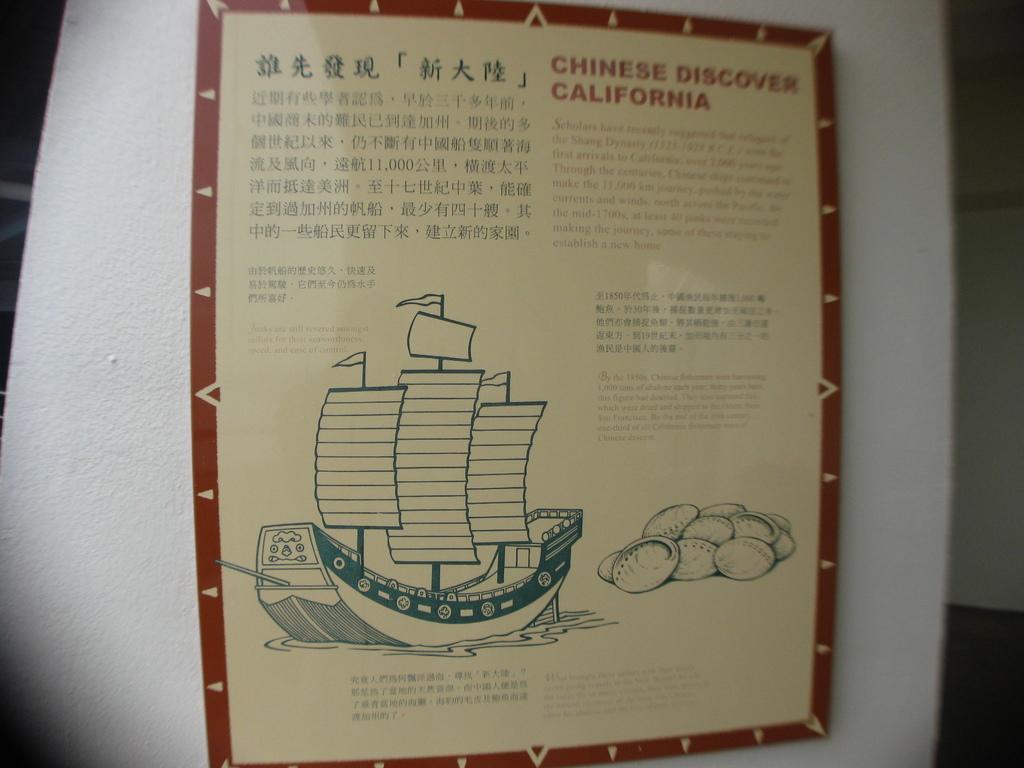Can you describe this image briefly? A board is on the wall. On this board there is a picture of boat.  